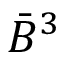Convert formula to latex. <formula><loc_0><loc_0><loc_500><loc_500>{ \bar { B } } ^ { 3 }</formula> 